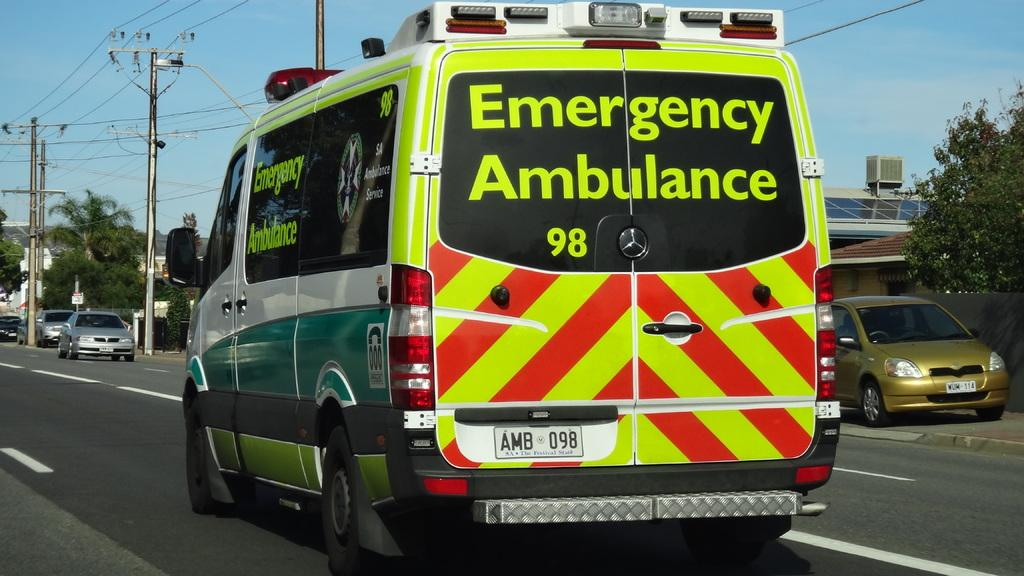<image>
Provide a brief description of the given image. an emergency ambulance that is on the street 